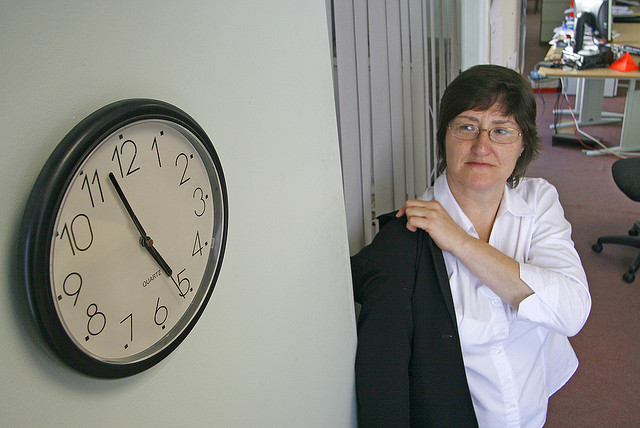Identify and read out the text in this image. 12 1 2 3 4 5 6 1 8 9 QUARTZ 10 11 